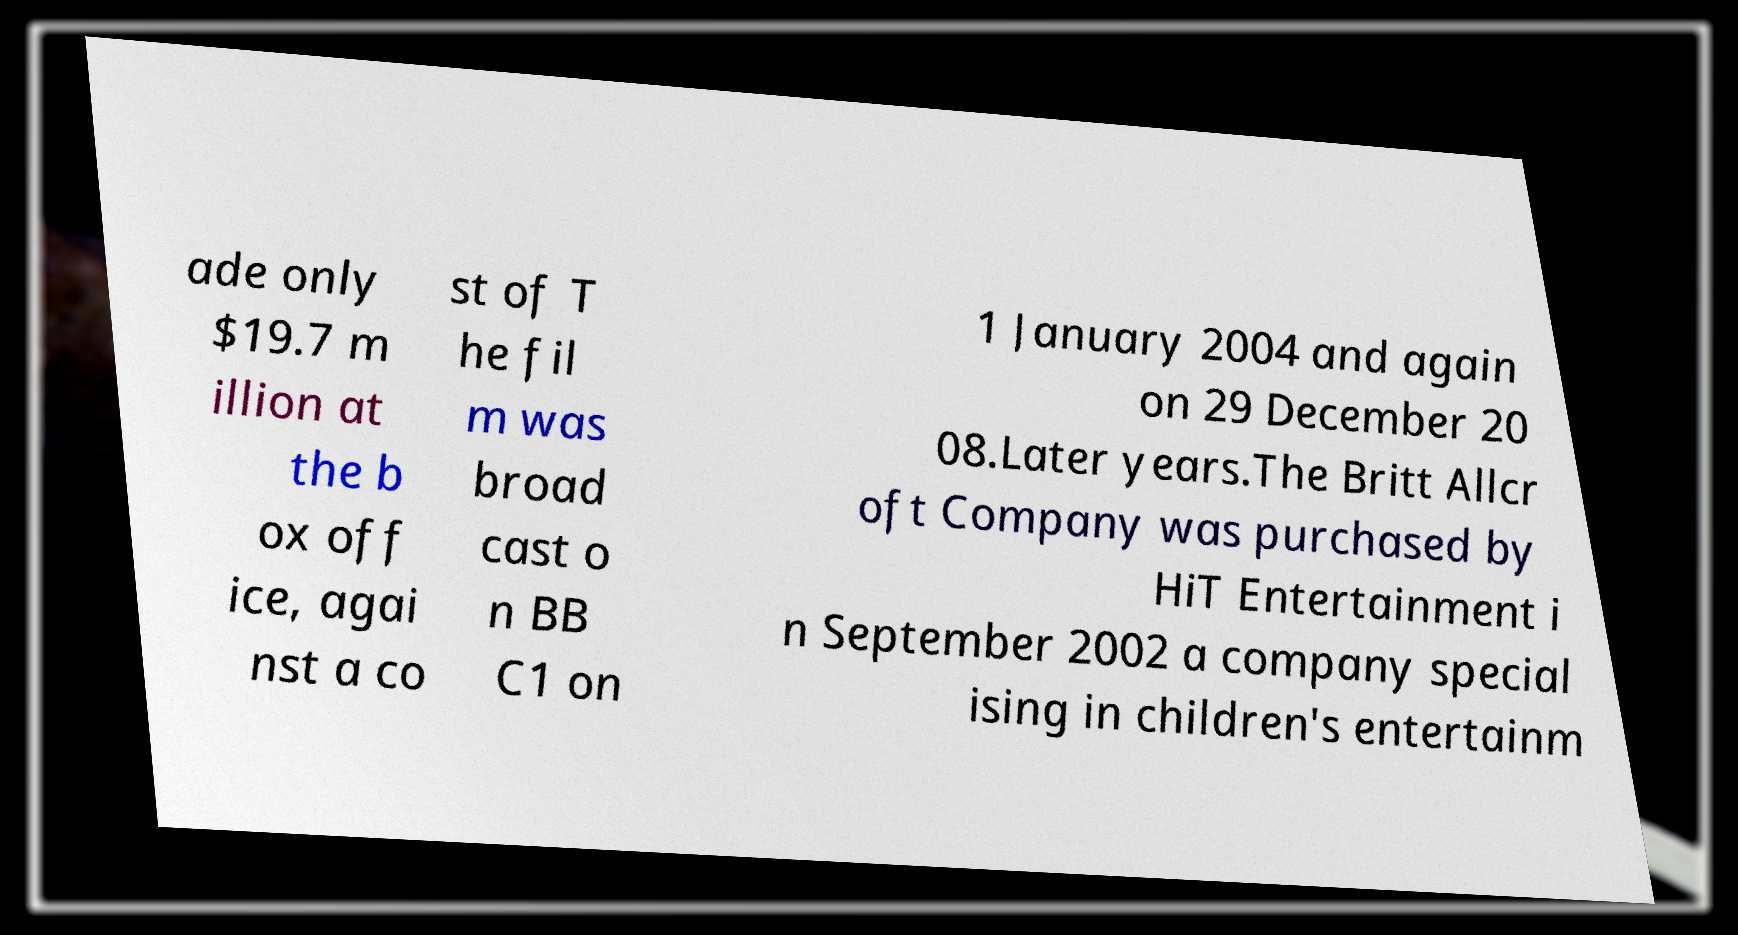Please read and relay the text visible in this image. What does it say? ade only $19.7 m illion at the b ox off ice, agai nst a co st of T he fil m was broad cast o n BB C1 on 1 January 2004 and again on 29 December 20 08.Later years.The Britt Allcr oft Company was purchased by HiT Entertainment i n September 2002 a company special ising in children's entertainm 